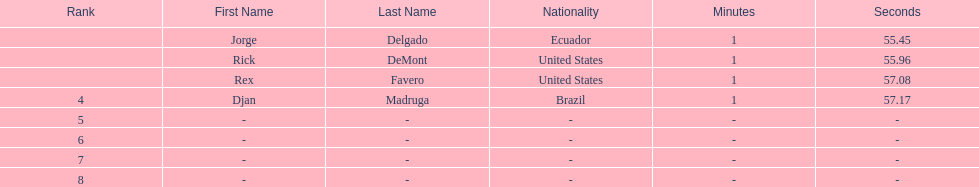Who finished with the top time? Jorge Delgado. 